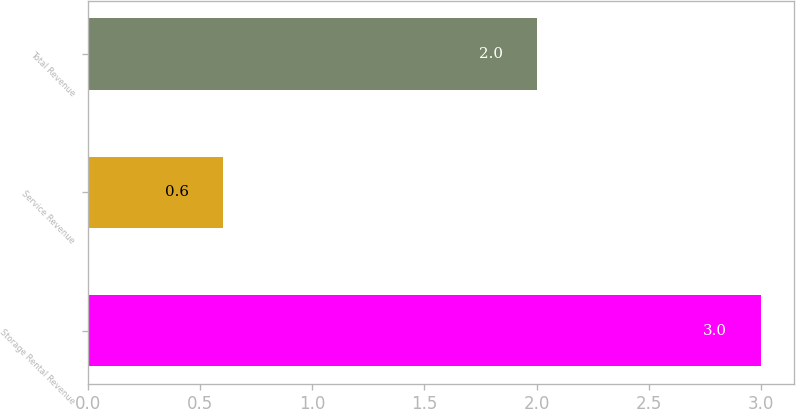Convert chart. <chart><loc_0><loc_0><loc_500><loc_500><bar_chart><fcel>Storage Rental Revenue<fcel>Service Revenue<fcel>Total Revenue<nl><fcel>3<fcel>0.6<fcel>2<nl></chart> 